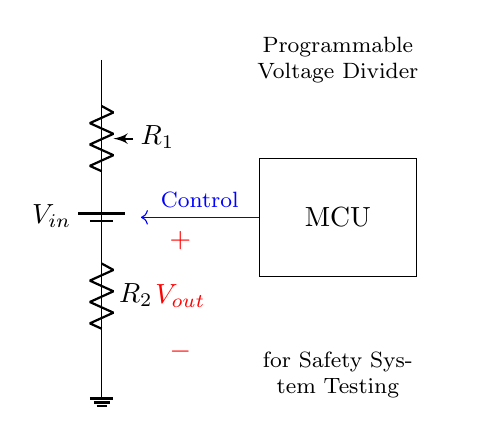What components are present in the circuit? The circuit includes a battery, a programmable resistor (potentiometer), a fixed resistor, a microcontroller, and a ground connection.
Answer: battery, programmable resistor, fixed resistor, microcontroller, ground What is the purpose of the microcontroller in this circuit? The microcontroller is used to control the programmable resistor for adjusting the voltage output, which simulates various fault conditions during testing.
Answer: Control voltage output What is the expected output voltage expression for this voltage divider? The output voltage can be expressed as Vout = Vin * (R2 / (R1 + R2)), where R1 is the programmable resistor and R2 is the fixed resistor.
Answer: Vout = Vin * (R2 / (R1 + R2)) How does changing R1 affect the output voltage? Changing R1 alters the voltage divider ratio, thus modifying the output voltage Vout. A decrease in R1 increases Vout, while an increase in R1 decreases Vout.
Answer: Modifies Vout Which resistor is adjustable in this circuit? The programmable resistor R1 is adjustable because it can be set to different resistance values to change the output voltage.
Answer: R1 What component simulates fault conditions during safety system testing? The programmable resistor R1 simulates fault conditions by allowing variable resistance changes, affecting the voltage level in the circuit.
Answer: R1 What is the direction of the control line connected to the microcontroller? The control line connected to the microcontroller runs in a blue arrow direction toward R1, indicating the adjustment signal's flow.
Answer: Left to right 